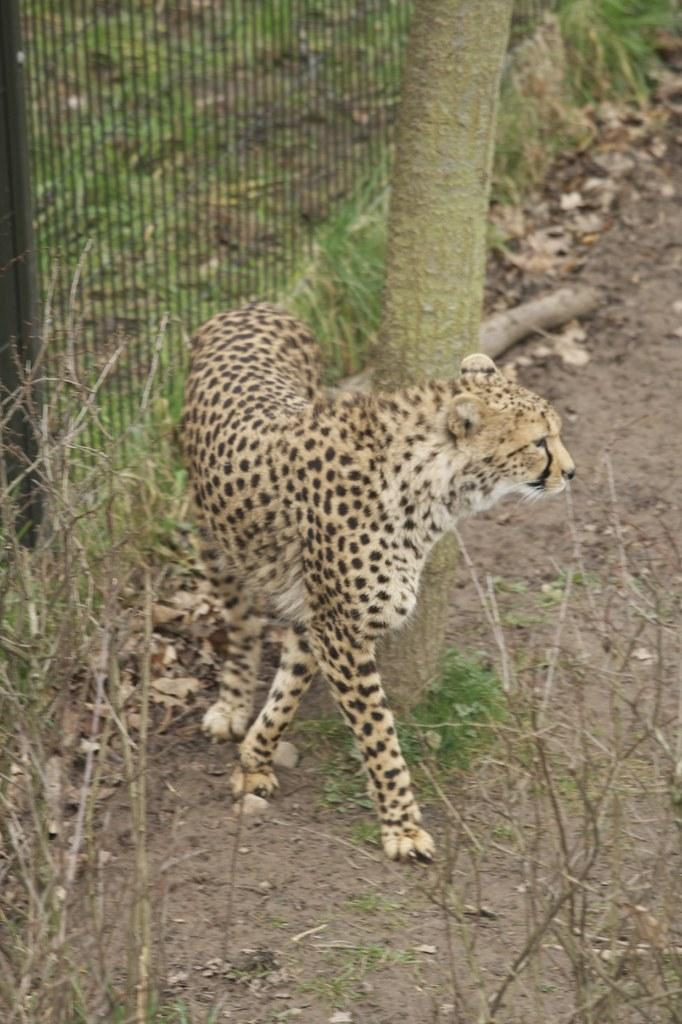What type of living organisms can be seen in the image? Plants can be seen in the image. What type of structure is present in the image? There is a fence in the image. What is the chita doing in the image? The chita (or an object resembling a cheetah) is present in the image. What part of a tree is visible in the image? There is a tree stem in the image. Can you tell me how many trees are visible in the image? The provided facts only mention a tree stem, not a full tree, so it cannot be definitively determined how many trees are visible in the image. What type of zoo animal is running in the image? There is no zoo animal running in the image; the chita (or an object resembling a cheetah) is present but not running. 